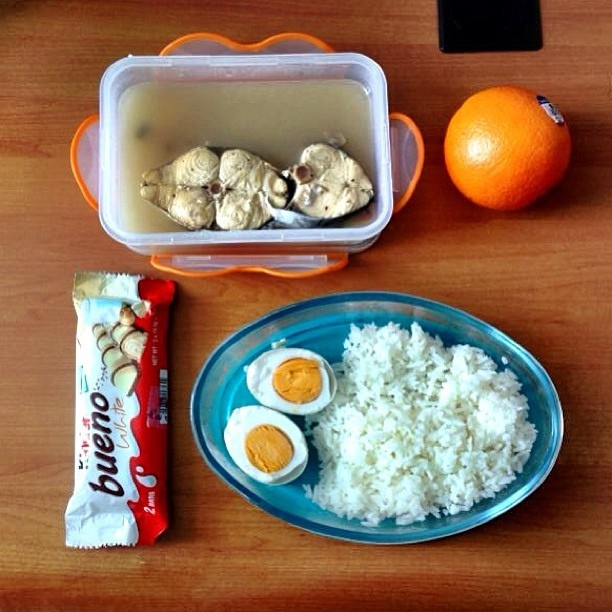Describe the objects in this image and their specific colors. I can see dining table in brown, maroon, gray, and lightblue tones, bowl in maroon, lightblue, teal, and darkgray tones, bowl in maroon, tan, lightgray, gray, and darkgray tones, and orange in maroon, orange, and red tones in this image. 